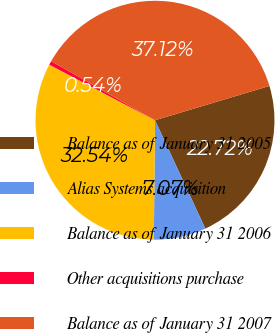Convert chart to OTSL. <chart><loc_0><loc_0><loc_500><loc_500><pie_chart><fcel>Balance as of January 31 2005<fcel>Alias Systems acquisition<fcel>Balance as of January 31 2006<fcel>Other acquisitions purchase<fcel>Balance as of January 31 2007<nl><fcel>22.72%<fcel>7.07%<fcel>32.54%<fcel>0.54%<fcel>37.12%<nl></chart> 